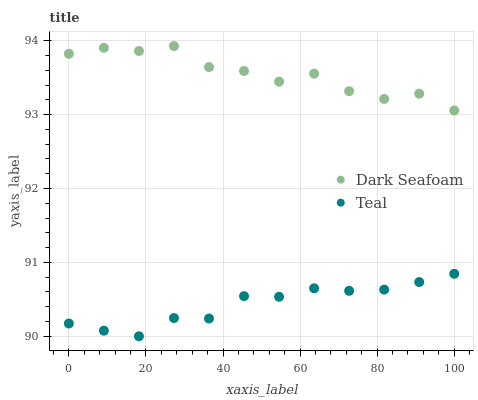Does Teal have the minimum area under the curve?
Answer yes or no. Yes. Does Dark Seafoam have the maximum area under the curve?
Answer yes or no. Yes. Does Teal have the maximum area under the curve?
Answer yes or no. No. Is Teal the smoothest?
Answer yes or no. Yes. Is Dark Seafoam the roughest?
Answer yes or no. Yes. Is Teal the roughest?
Answer yes or no. No. Does Teal have the lowest value?
Answer yes or no. Yes. Does Dark Seafoam have the highest value?
Answer yes or no. Yes. Does Teal have the highest value?
Answer yes or no. No. Is Teal less than Dark Seafoam?
Answer yes or no. Yes. Is Dark Seafoam greater than Teal?
Answer yes or no. Yes. Does Teal intersect Dark Seafoam?
Answer yes or no. No. 